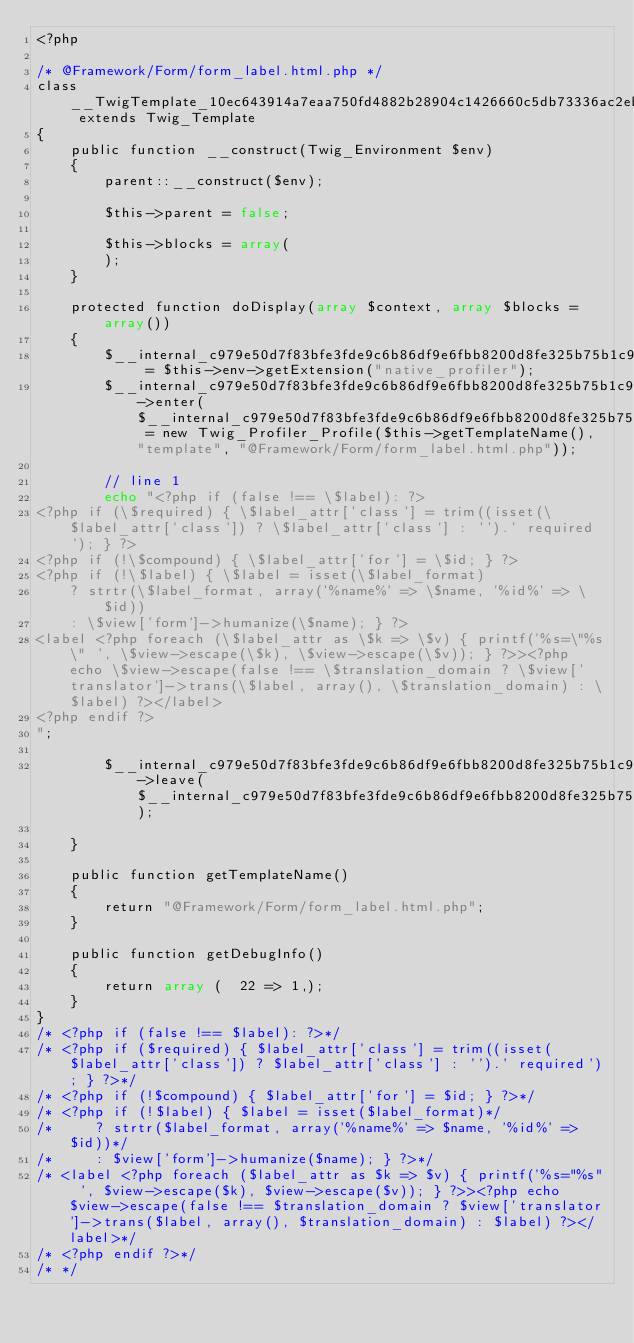<code> <loc_0><loc_0><loc_500><loc_500><_PHP_><?php

/* @Framework/Form/form_label.html.php */
class __TwigTemplate_10ec643914a7eaa750fd4882b28904c1426660c5db73336ac2ebed02edee911e extends Twig_Template
{
    public function __construct(Twig_Environment $env)
    {
        parent::__construct($env);

        $this->parent = false;

        $this->blocks = array(
        );
    }

    protected function doDisplay(array $context, array $blocks = array())
    {
        $__internal_c979e50d7f83bfe3fde9c6b86df9e6fbb8200d8fe325b75b1c9fd6b4463d961a = $this->env->getExtension("native_profiler");
        $__internal_c979e50d7f83bfe3fde9c6b86df9e6fbb8200d8fe325b75b1c9fd6b4463d961a->enter($__internal_c979e50d7f83bfe3fde9c6b86df9e6fbb8200d8fe325b75b1c9fd6b4463d961a_prof = new Twig_Profiler_Profile($this->getTemplateName(), "template", "@Framework/Form/form_label.html.php"));

        // line 1
        echo "<?php if (false !== \$label): ?>
<?php if (\$required) { \$label_attr['class'] = trim((isset(\$label_attr['class']) ? \$label_attr['class'] : '').' required'); } ?>
<?php if (!\$compound) { \$label_attr['for'] = \$id; } ?>
<?php if (!\$label) { \$label = isset(\$label_format)
    ? strtr(\$label_format, array('%name%' => \$name, '%id%' => \$id))
    : \$view['form']->humanize(\$name); } ?>
<label <?php foreach (\$label_attr as \$k => \$v) { printf('%s=\"%s\" ', \$view->escape(\$k), \$view->escape(\$v)); } ?>><?php echo \$view->escape(false !== \$translation_domain ? \$view['translator']->trans(\$label, array(), \$translation_domain) : \$label) ?></label>
<?php endif ?>
";
        
        $__internal_c979e50d7f83bfe3fde9c6b86df9e6fbb8200d8fe325b75b1c9fd6b4463d961a->leave($__internal_c979e50d7f83bfe3fde9c6b86df9e6fbb8200d8fe325b75b1c9fd6b4463d961a_prof);

    }

    public function getTemplateName()
    {
        return "@Framework/Form/form_label.html.php";
    }

    public function getDebugInfo()
    {
        return array (  22 => 1,);
    }
}
/* <?php if (false !== $label): ?>*/
/* <?php if ($required) { $label_attr['class'] = trim((isset($label_attr['class']) ? $label_attr['class'] : '').' required'); } ?>*/
/* <?php if (!$compound) { $label_attr['for'] = $id; } ?>*/
/* <?php if (!$label) { $label = isset($label_format)*/
/*     ? strtr($label_format, array('%name%' => $name, '%id%' => $id))*/
/*     : $view['form']->humanize($name); } ?>*/
/* <label <?php foreach ($label_attr as $k => $v) { printf('%s="%s" ', $view->escape($k), $view->escape($v)); } ?>><?php echo $view->escape(false !== $translation_domain ? $view['translator']->trans($label, array(), $translation_domain) : $label) ?></label>*/
/* <?php endif ?>*/
/* */
</code> 